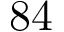Convert formula to latex. <formula><loc_0><loc_0><loc_500><loc_500>8 4</formula> 